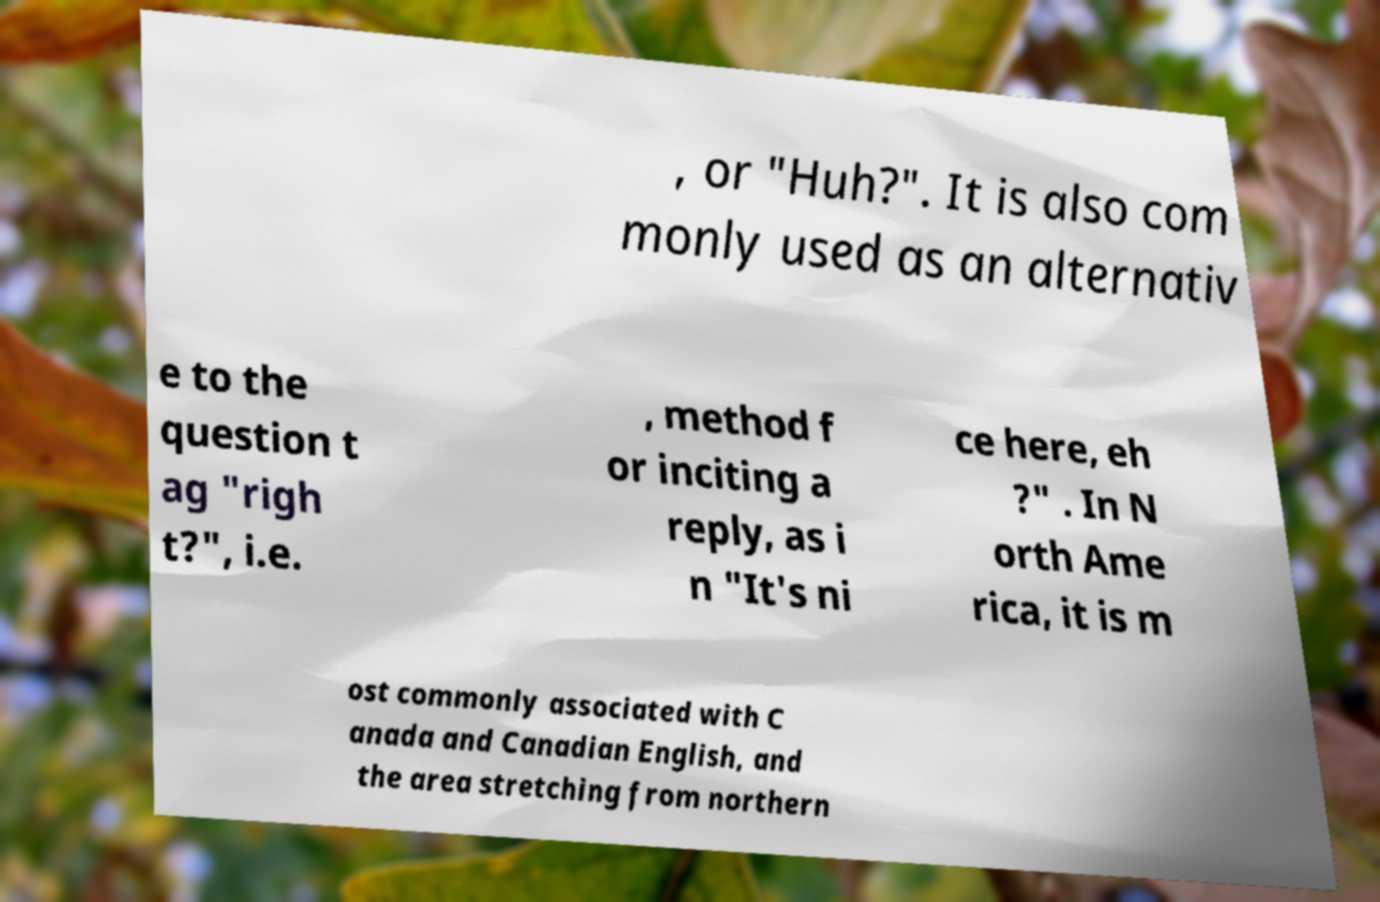Please read and relay the text visible in this image. What does it say? , or "Huh?". It is also com monly used as an alternativ e to the question t ag "righ t?", i.e. , method f or inciting a reply, as i n "It's ni ce here, eh ?" . In N orth Ame rica, it is m ost commonly associated with C anada and Canadian English, and the area stretching from northern 